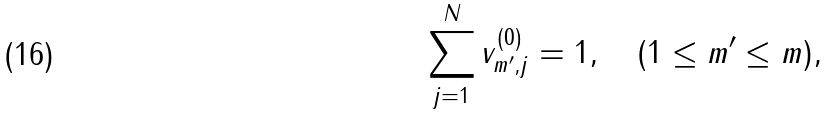<formula> <loc_0><loc_0><loc_500><loc_500>\sum _ { j = 1 } ^ { N } v ^ { ( 0 ) } _ { m ^ { \prime } , j } = 1 , \quad ( 1 \leq m ^ { \prime } \leq m ) ,</formula> 